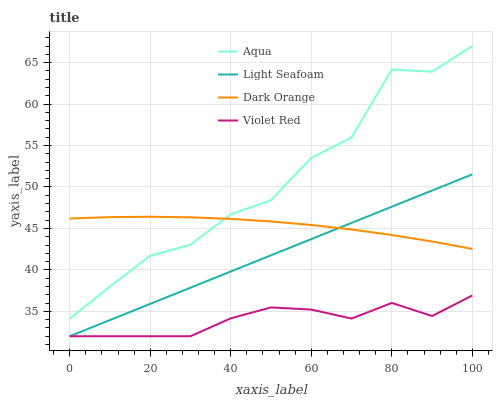Does Violet Red have the minimum area under the curve?
Answer yes or no. Yes. Does Aqua have the maximum area under the curve?
Answer yes or no. Yes. Does Light Seafoam have the minimum area under the curve?
Answer yes or no. No. Does Light Seafoam have the maximum area under the curve?
Answer yes or no. No. Is Light Seafoam the smoothest?
Answer yes or no. Yes. Is Aqua the roughest?
Answer yes or no. Yes. Is Violet Red the smoothest?
Answer yes or no. No. Is Violet Red the roughest?
Answer yes or no. No. Does Aqua have the lowest value?
Answer yes or no. No. Does Aqua have the highest value?
Answer yes or no. Yes. Does Light Seafoam have the highest value?
Answer yes or no. No. Is Violet Red less than Aqua?
Answer yes or no. Yes. Is Aqua greater than Violet Red?
Answer yes or no. Yes. Does Violet Red intersect Aqua?
Answer yes or no. No. 